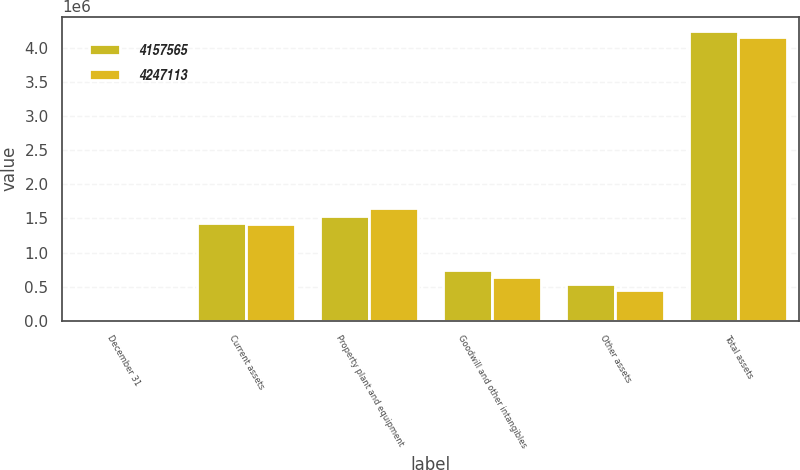<chart> <loc_0><loc_0><loc_500><loc_500><stacked_bar_chart><ecel><fcel>December 31<fcel>Current assets<fcel>Property plant and equipment<fcel>Goodwill and other intangibles<fcel>Other assets<fcel>Total assets<nl><fcel>4.15756e+06<fcel>2007<fcel>1.42657e+06<fcel>1.53972e+06<fcel>740575<fcel>540249<fcel>4.24711e+06<nl><fcel>4.24711e+06<fcel>2006<fcel>1.41781e+06<fcel>1.6513e+06<fcel>642269<fcel>446184<fcel>4.15756e+06<nl></chart> 